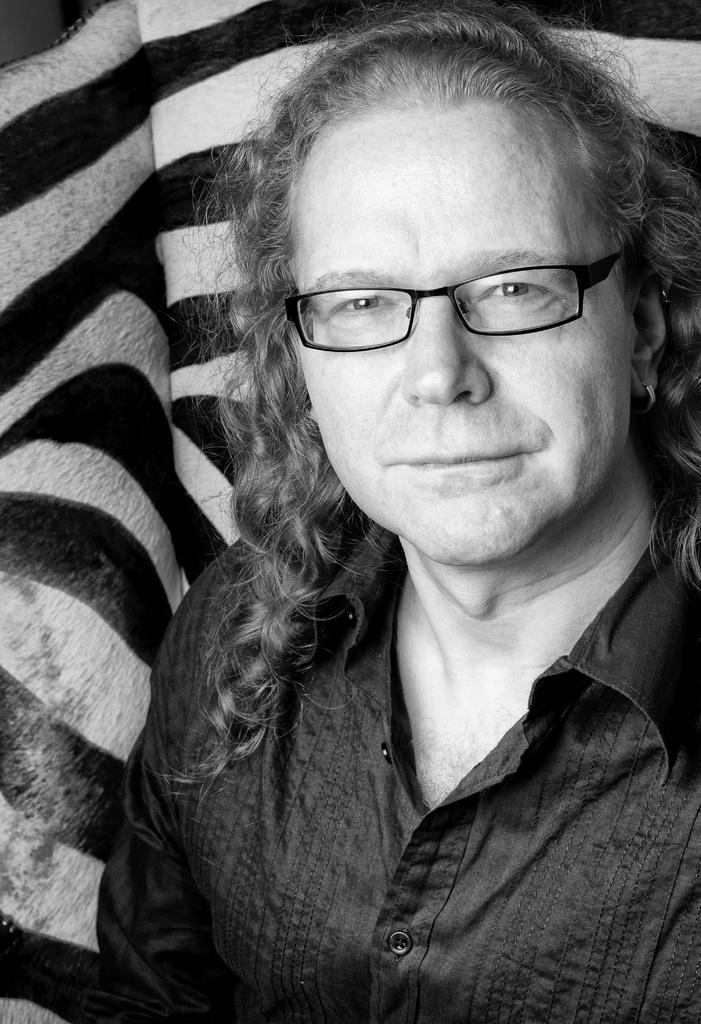What is the main subject of the image? There is a person in the image. Can you describe the person's appearance? The person is wearing spectacles. What is the person doing in the image? The person is sitting on a sofa chair. How can you describe the sofa chair's appearance? The sofa chair has a white and black color pattern. What type of vegetable is being used as a cushion for the person in the image? There is no vegetable present in the image, and the person is sitting on a sofa chair, not a vegetable. 